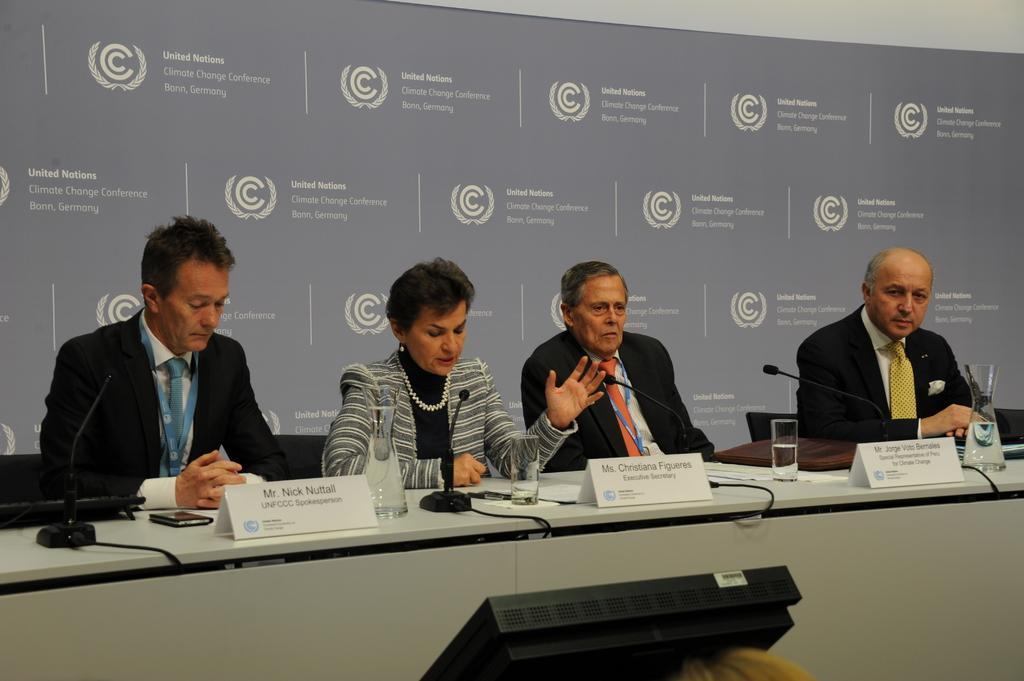What are the people in the image doing? The people in the image are sitting at the desk. What objects can be seen on the desk? There are mice, glasses, and boards on the desk. What is the purpose of the glasses on the desk? The purpose of the glasses on the desk is not clear from the image, but they might be used for drinking or holding objects. What is visible in the background of the image? There is a wall in the background of the image. What type of language is being spoken by the mice in the image? There are no mice speaking in the image; they are simply objects on the desk. What kind of feast is being prepared on the desk? There is no feast being prepared on the desk; the objects on the desk are mice, glasses, and boards. 